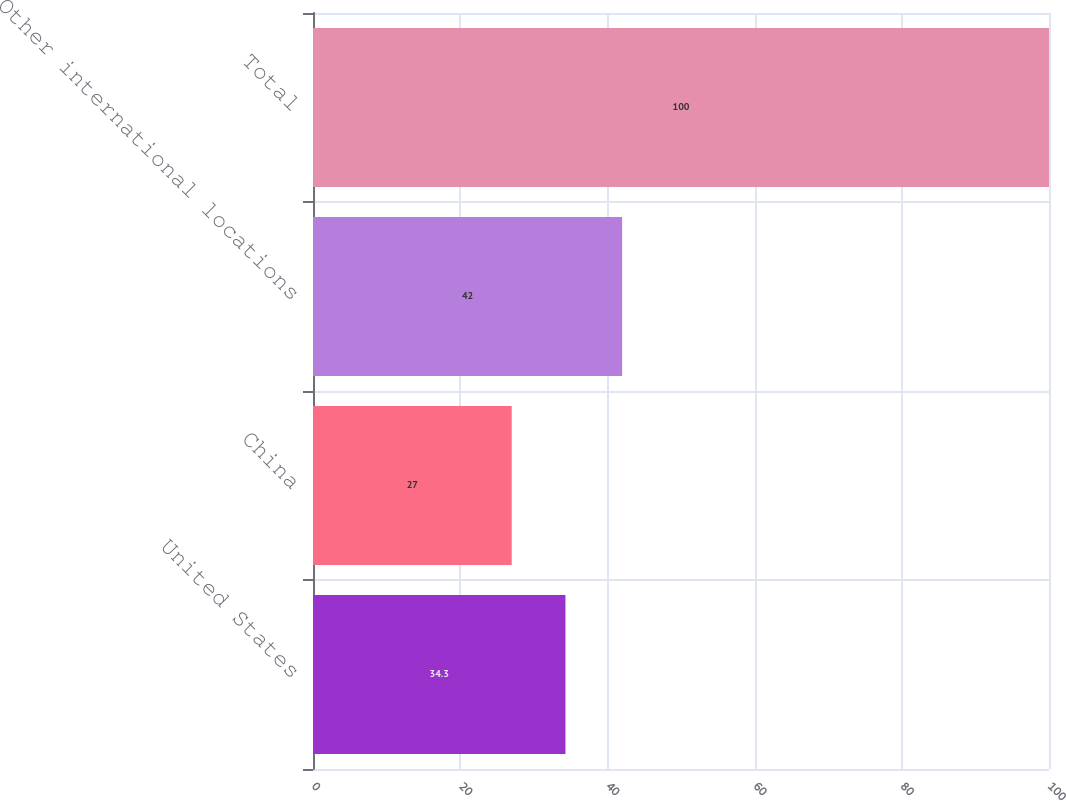Convert chart to OTSL. <chart><loc_0><loc_0><loc_500><loc_500><bar_chart><fcel>United States<fcel>China<fcel>Other international locations<fcel>Total<nl><fcel>34.3<fcel>27<fcel>42<fcel>100<nl></chart> 